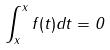Convert formula to latex. <formula><loc_0><loc_0><loc_500><loc_500>\int _ { x } ^ { x } f ( t ) d t = 0</formula> 